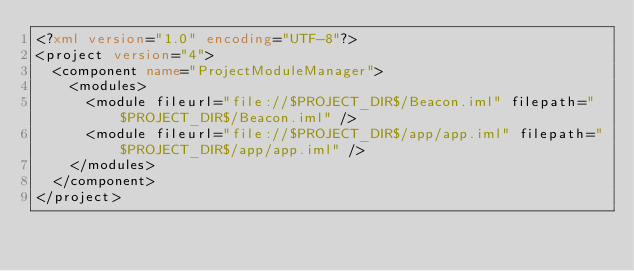Convert code to text. <code><loc_0><loc_0><loc_500><loc_500><_XML_><?xml version="1.0" encoding="UTF-8"?>
<project version="4">
  <component name="ProjectModuleManager">
    <modules>
      <module fileurl="file://$PROJECT_DIR$/Beacon.iml" filepath="$PROJECT_DIR$/Beacon.iml" />
      <module fileurl="file://$PROJECT_DIR$/app/app.iml" filepath="$PROJECT_DIR$/app/app.iml" />
    </modules>
  </component>
</project></code> 